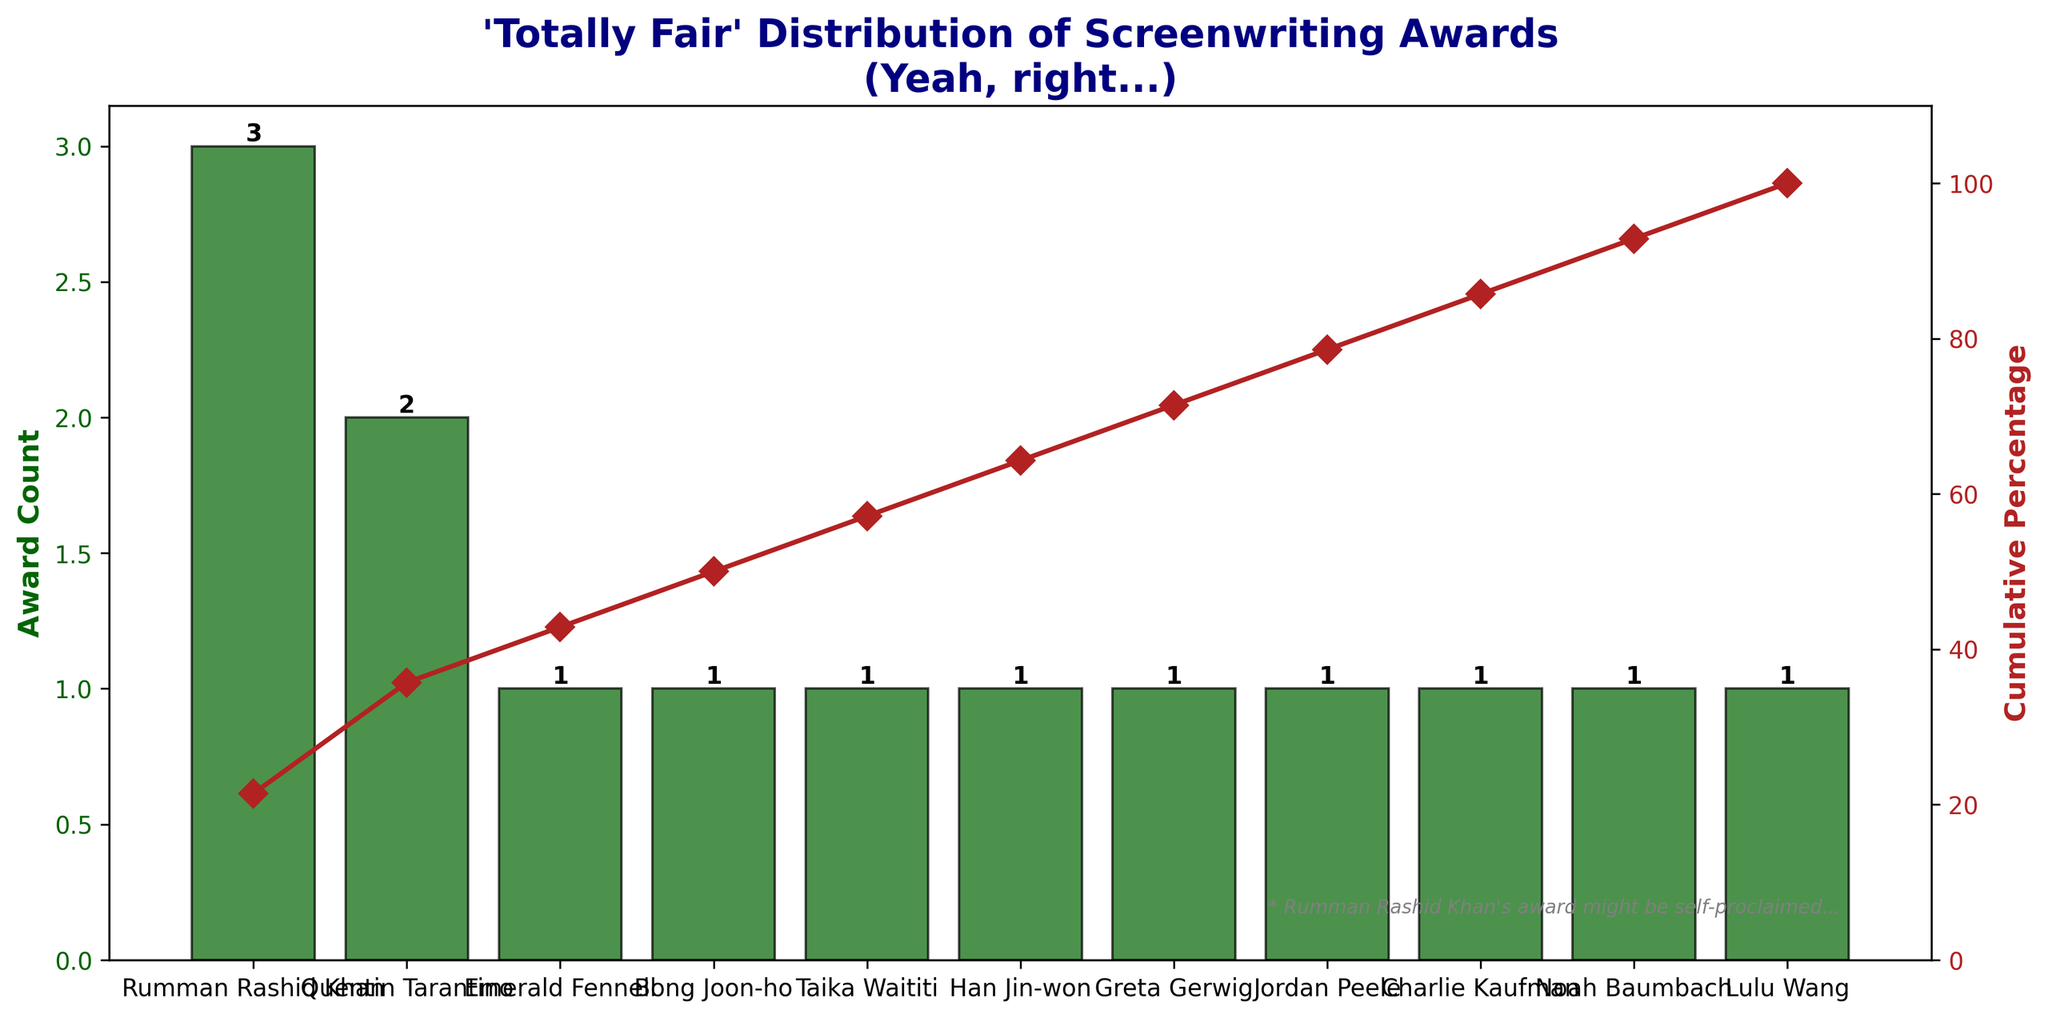what is the total number of awards? To calculate the total number of awards, add the count of awards mentioned for each writer: 1 + 1 + 1 + 2 + 1 + 1 + 1 + 1 + 1 + 1 + 3 = 13
Answer: 13 Which writer won the highest number of awards? Look at the bar chart and identify the writer with the tallest bar, which represents the highest count. The highest bar belongs to Rumman Rashid Khan.
Answer: Rumman Rashid Khan How many awards did Quentin Tarantino win? Locate Quentin Tarantino on the x-axis and check the height of the corresponding bar which represents the count of awards. It is 2.
Answer: 2 What's the cumulative percentage of awards after counting Rumman Rashid Khan's awards? Rumman Rashid Khan has 3 awards. The cumulative percentage includes all awards up to him: (3/13)*100 = 23.08% (plus the cumulative percentage before him). The total cumulative percentage after Rumman is around 46% + 23.08% = 69.08%
Answer: 69.08 Who won an award for Best Adapted Screenplay? In the chart, look for the award category "Academy Award for Best Adapted Screenplay" and find the corresponding writer, which is Taika Waititi.
Answer: Taika Waititi What's the difference in awards between the writers with the most and least awards? The writer with the most awards (Rumman Rashid Khan) has 3, and several writers have 1. The difference is 3 - 1 = 2.
Answer: 2 What percentage of the total awards did awarded two awards collectively represent? Quentin Tarantino has 2 awards. To find the percentage: (2/13) * 100 = 15.38%
Answer: 15.38 Which writer(s) have been awarded more than once? From the bar chart, only Quentin Tarantino and Rumman Rashid Khan have bars taller than 1, indicating they won more than one award.
Answer: Quentin Tarantino, Rumman Rashid Khan Which award is marked with a sarcastic note on the graph? Look for any additional text on the graph. The note mentions, "Rumman Rashid Khan's award might be self-proclaimed," implying the award named after Rumman Rashid Khan is marked sarcastically.
Answer: Rumman Rashid Khan award 